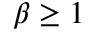Convert formula to latex. <formula><loc_0><loc_0><loc_500><loc_500>\beta \geq 1</formula> 